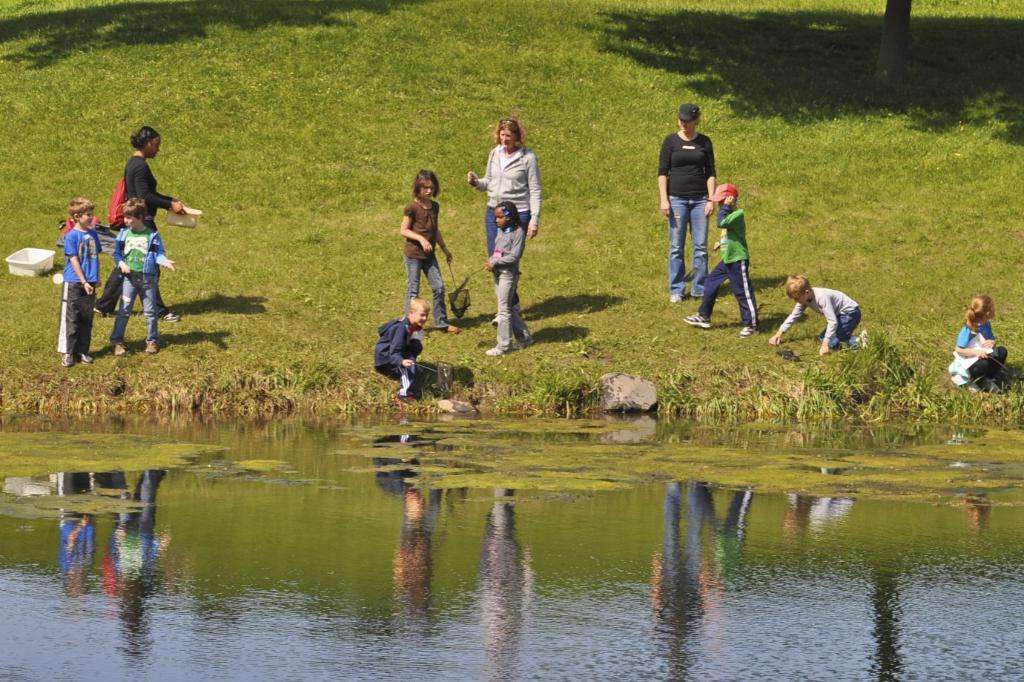What is the main subject of the image? The main subject of the image is a group of people. Where are the people located in the image? The people are standing on the grass. Can you describe the clothing of one of the people in the image? One person is wearing a yellow shirt and gray pants. What can be seen in the background of the image? The background of the image includes green grass. grass. What type of doll is sitting on the egg in the image? There is no doll or egg present in the image; it features a group of people standing on the grass. 